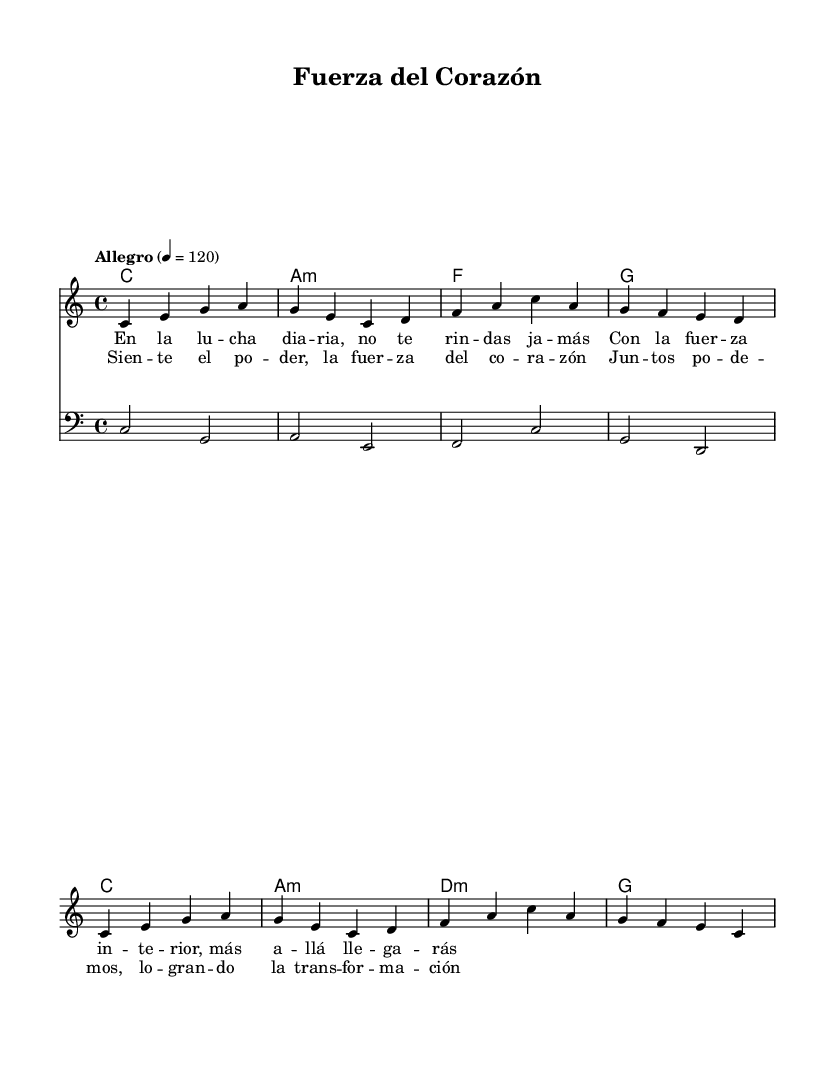What is the key signature of this music? The key signature is indicated at the beginning of the staff, showing no sharps or flats, which corresponds to C major.
Answer: C major What is the time signature of the piece? The time signature is noted at the beginning of the score, showing a 4 over 4, which means there are four beats in each measure and a quarter note gets one beat.
Answer: 4/4 What tempo marking is given for the song? The tempo marking, found at the start of the score, is "Allegro" with a specific metronome marking of 120, which indicates a fast, lively tempo.
Answer: Allegro, 120 How many measures are in the chorus of the song? The chorus is identified separately from the verse and consists of four lines of lyrics, each typically representing a measure, indicating there are four measures in the chorus.
Answer: 4 measures What is the first chord of the piece? The first chord is displayed in the chord names staff and shows "C," which is the chord that starts the progression.
Answer: C Which instrument is indicated for the bass part? The clef at the beginning of the bass staff is a bass clef, which indicates that this part is specifically written for a bass instrument.
Answer: Bass clef What themes do the lyrics of this piece convey? The lyrics express themes of empowerment and resilience, emphasizing inner strength and transformation, which are common in uplifting Latin pop songs.
Answer: Empowerment and resilience 